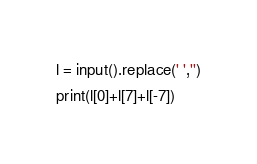Convert code to text. <code><loc_0><loc_0><loc_500><loc_500><_Python_>l = input().replace(' ','')
print(l[0]+l[7]+l[-7])

</code> 